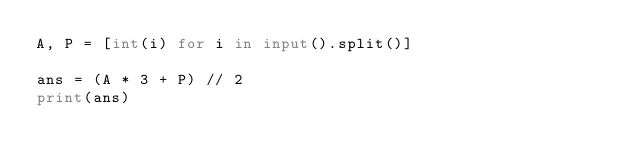<code> <loc_0><loc_0><loc_500><loc_500><_Python_>A, P = [int(i) for i in input().split()]

ans = (A * 3 + P) // 2
print(ans)</code> 